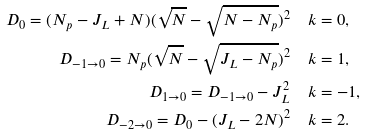Convert formula to latex. <formula><loc_0><loc_0><loc_500><loc_500>D _ { 0 } = ( N _ { p } - J _ { L } + N ) ( \sqrt { N } - \sqrt { N - N _ { p } } ) ^ { 2 } & \quad k = 0 , \\ D _ { - 1 \to 0 } = N _ { p } ( \sqrt { N } - \sqrt { J _ { L } - N _ { p } } ) ^ { 2 } & \quad k = 1 , \\ D _ { 1 \to 0 } = D _ { - 1 \to 0 } - J _ { L } ^ { 2 } & \quad k = - 1 , \\ D _ { - 2 \to 0 } = D _ { 0 } - ( J _ { L } - 2 N ) ^ { 2 } & \quad k = 2 .</formula> 